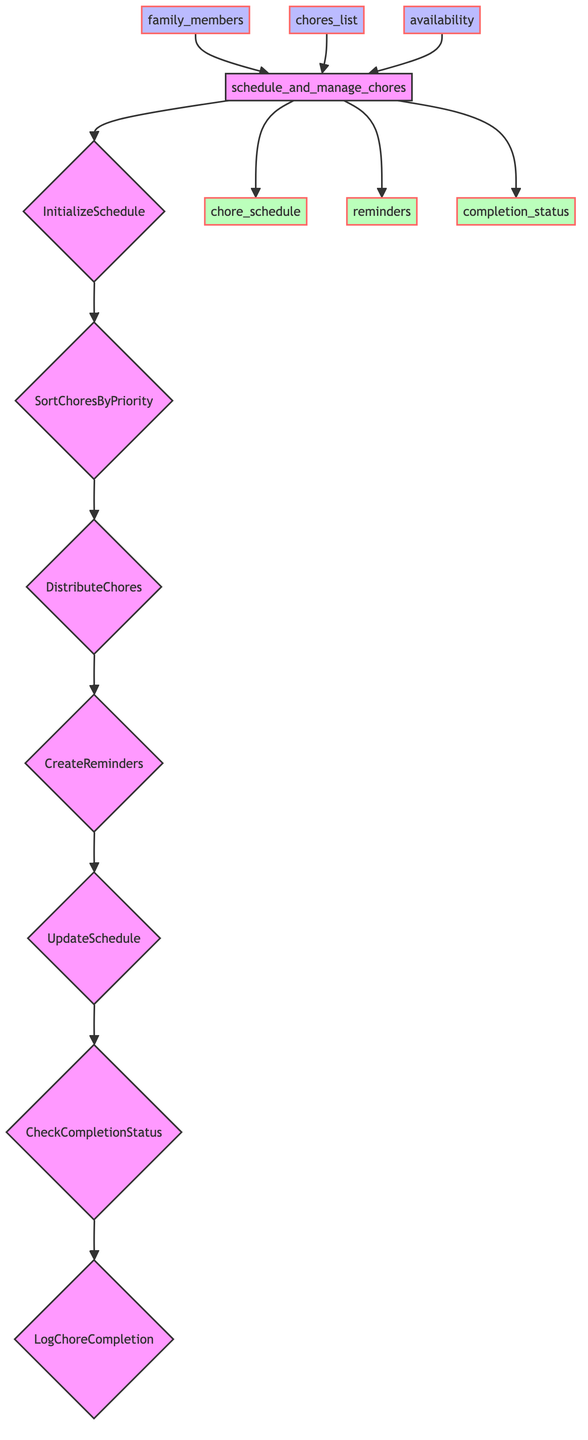What are the inputs to the function? The inputs are specified in the diagram as "family_members," "chores_list," and "availability."
Answer: family_members, chores_list, availability What is the last step of the process? The last step in the flowchart is labeled "LogChoreCompletion," indicating that this is the final action followed in the function.
Answer: LogChoreCompletion How many steps are there in the function? Counting the steps outlined in the flowchart, there are a total of 7 distinct steps listed.
Answer: 7 What is produced as an output of the function? The outputs in the function are shown as "chore_schedule," "reminders," and "completion_status."
Answer: chore_schedule, reminders, completion_status Which step comes immediately after "CreateReminders"? The flowchart indicates that the step that follows "CreateReminders" is "UpdateSchedule," connecting these two processes.
Answer: UpdateSchedule How does "DistributeChores" relate to "SortChoresByPriority"? "SortChoresByPriority" directly precedes "DistributeChores" in the flowchart, meaning that sorting the chores by priority is necessary before distributing them to family members.
Answer: Sorting precedes distributing What step is responsible for tracking the status of chores? The step specifically dedicated to tracking the status is "CheckCompletionStatus," shown clearly as part of the sequential process in the diagram.
Answer: CheckCompletionStatus What comes before "LogChoreCompletion"? According to the diagram, "CheckCompletionStatus" is the step that directly comes before "LogChoreCompletion."
Answer: CheckCompletionStatus 